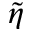<formula> <loc_0><loc_0><loc_500><loc_500>\tilde { \eta }</formula> 